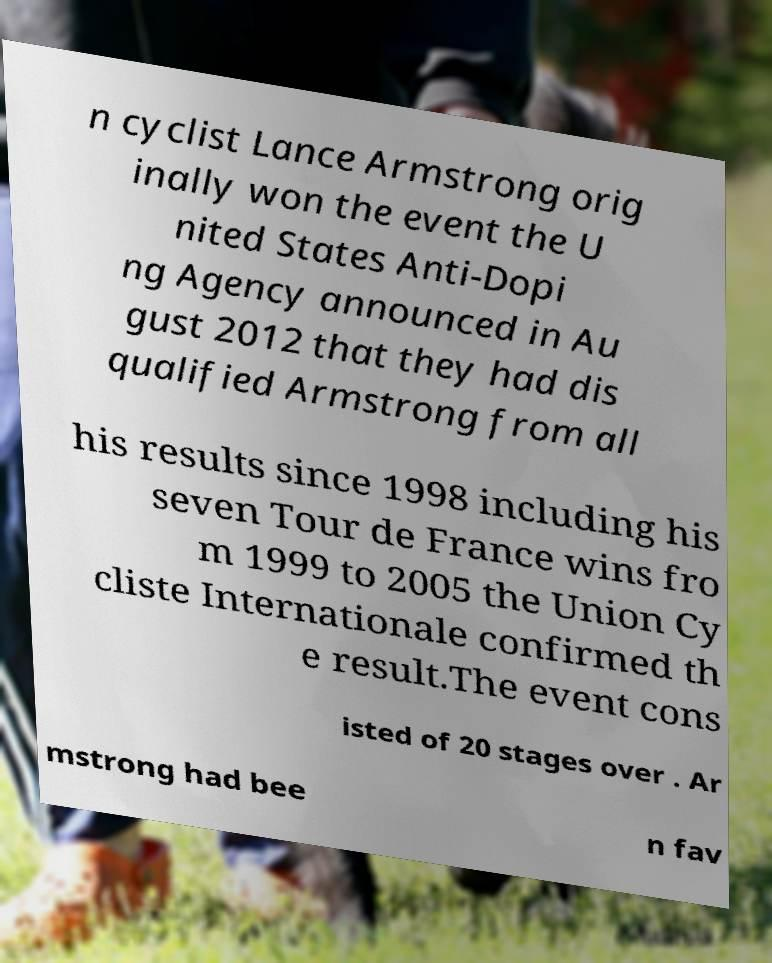Could you extract and type out the text from this image? n cyclist Lance Armstrong orig inally won the event the U nited States Anti-Dopi ng Agency announced in Au gust 2012 that they had dis qualified Armstrong from all his results since 1998 including his seven Tour de France wins fro m 1999 to 2005 the Union Cy cliste Internationale confirmed th e result.The event cons isted of 20 stages over . Ar mstrong had bee n fav 